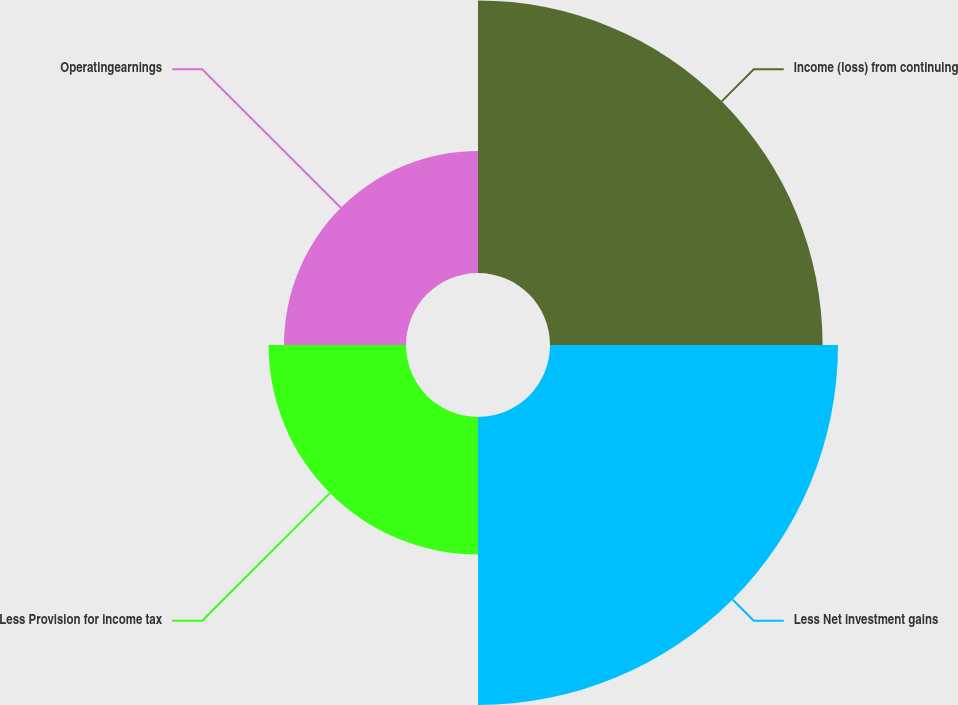<chart> <loc_0><loc_0><loc_500><loc_500><pie_chart><fcel>Income (loss) from continuing<fcel>Less Net investment gains<fcel>Less Provision for income tax<fcel>Operatingearnings<nl><fcel>33.24%<fcel>35.12%<fcel>16.76%<fcel>14.88%<nl></chart> 